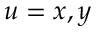Convert formula to latex. <formula><loc_0><loc_0><loc_500><loc_500>u = x , y</formula> 